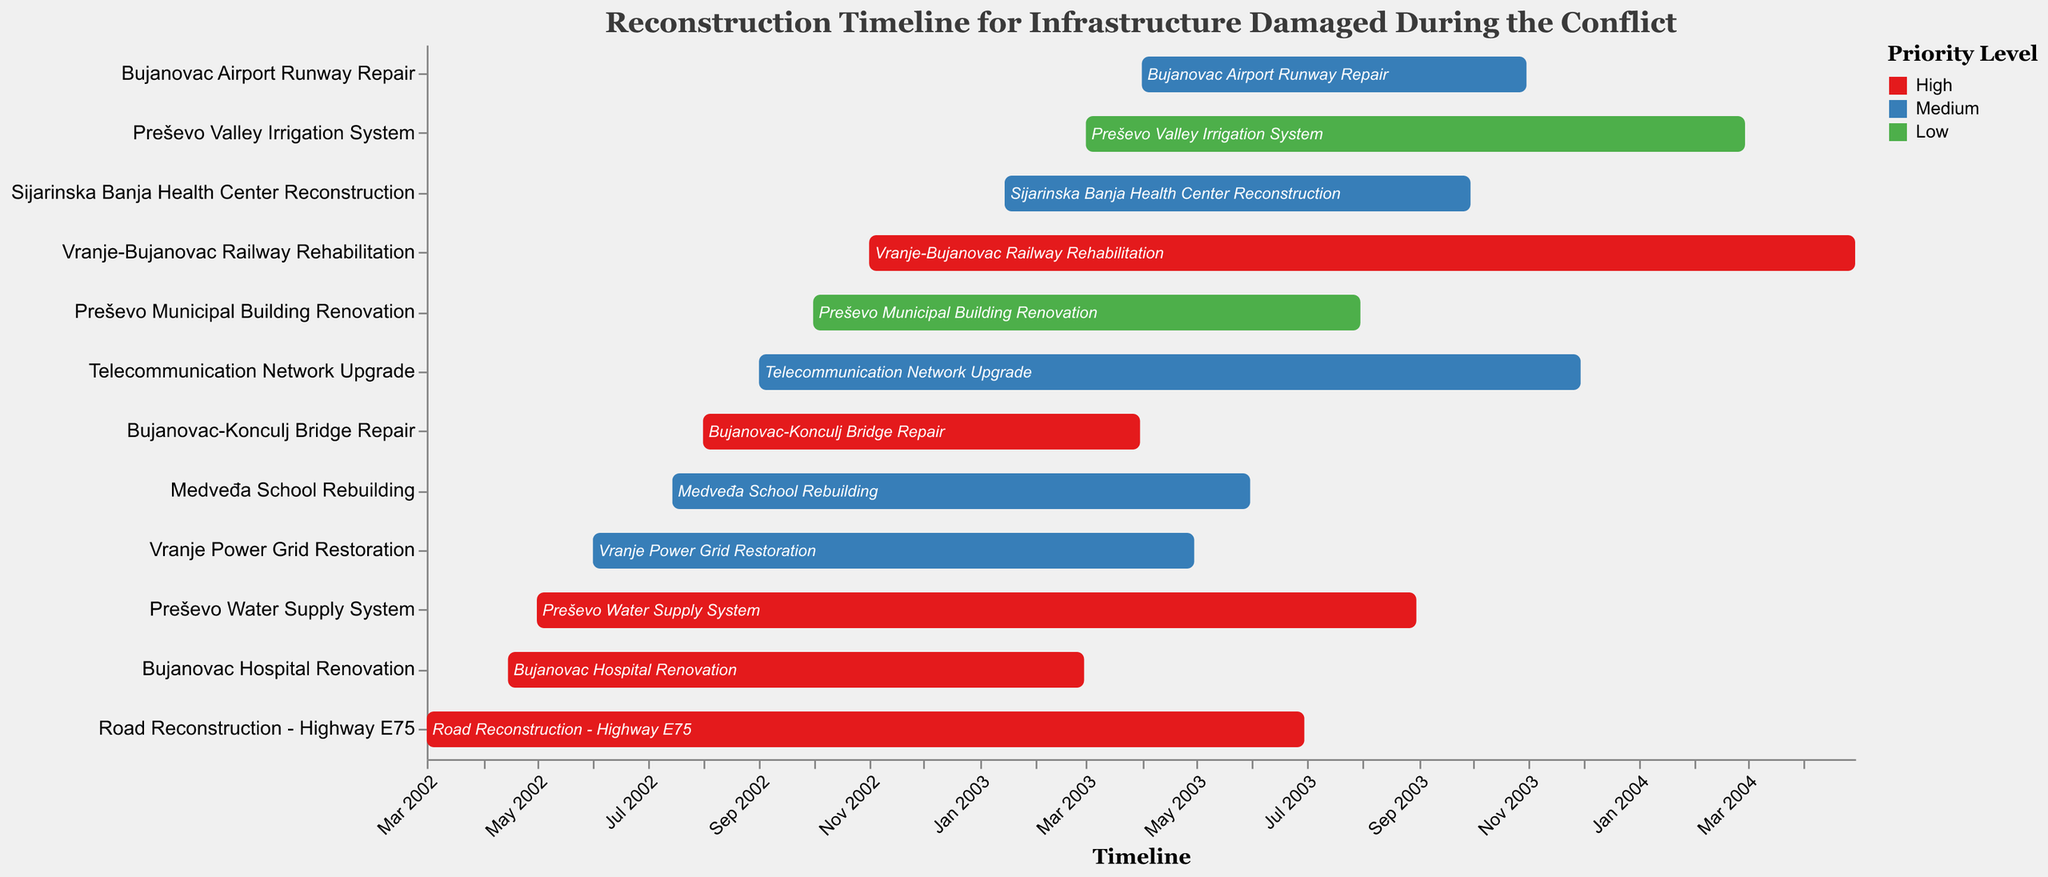What is the title of the chart? The title of the chart is displayed prominently at the top. It reads "Reconstruction Timeline for Infrastructure Damaged During the Conflict".
Answer: Reconstruction Timeline for Infrastructure Damaged During the Conflict How many projects are classified as "High" priority? By looking at the color legend and counting the projects encoded with the "High" priority color, you can determine there are 5 such projects.
Answer: 5 Which project has the longest duration? To find the project with the longest duration, compare the "Start Date" and "End Date" of each project, and calculate the duration. The "Vranje-Bujanovac Railway Rehabilitation" project starts in Nov 2002 and ends in Apr 2004, lasting approximately 18 months.
Answer: Vranje-Bujanovac Railway Rehabilitation Which projects were started in 2003? By examining the "Start Date" column, the projects that started in 2003 are "Sijarinska Banja Health Center Reconstruction", "Preševo Valley Irrigation System", and "Bujanovac Airport Runway Repair".
Answer: Sijarinska Banja Health Center Reconstruction, Preševo Valley Irrigation System, Bujanovac Airport Runway Repair How many projects have an ending date after August 2003? To determine the projects ending after August 2003, we look for "End Date" values beyond this date. The projects are "Preševo Water Supply System", "Telecommunication Network Upgrade", "Vranje-Bujanovac Railway Rehabilitation", "Sijarinska Banja Health Center Reconstruction", "Preševo Valley Irrigation System", and "Bujanovac Airport Runway Repair".
Answer: 6 Which "High" priority project finished first? Among the "High" priority projects, the "Bujanovac Hospital Renovation" project finished first; it ended in February 2003.
Answer: Bujanovac Hospital Renovation List the "Medium" priority projects in order of their start date. The "Medium" priority projects are ordered by their start dates in the chart as "Vranje Power Grid Restoration" (June 2002), "Medveđa School Rebuilding" (July 2002), "Telecommunication Network Upgrade" (Sep 2002), "Sijarinska Banja Health Center Reconstruction" (Jan 2003), and "Bujanovac Airport Runway Repair" (Apr 2003).
Answer: Vranje Power Grid Restoration, Medveđa School Rebuilding, Telecommunication Network Upgrade, Sijarinska Banja Health Center Reconstruction, Bujanovac Airport Runway Repair What is the shortest duration project? By calculating the duration of each project from the "Start Date" to the "End Date", the shortest duration is "Bujanovac Hospital Renovation" lasting from April 2002 to February 2003, approximately 10.5 months.
Answer: Bujanovac Hospital Renovation 